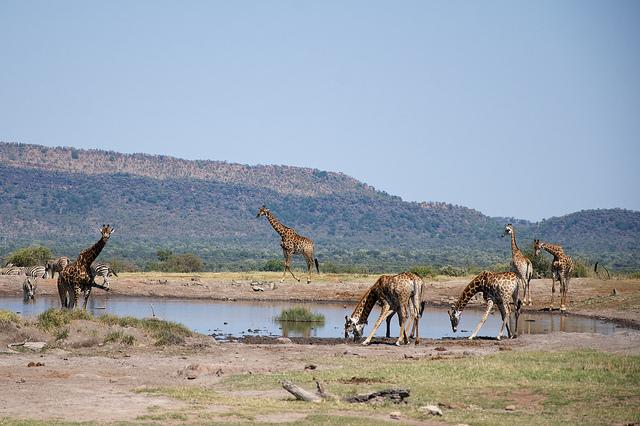How many of the giraffes are taking a drink in the water? Please explain your reasoning. six. The giraffes are characteristic by their long necks and there are some in front and behind the pond.  they are in contrast to the striped zebras. 